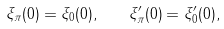Convert formula to latex. <formula><loc_0><loc_0><loc_500><loc_500>\xi _ { \pi } ( 0 ) = \xi _ { 0 } ( 0 ) , \quad \xi _ { \pi } ^ { \prime } ( 0 ) = \xi _ { 0 } ^ { \prime } ( 0 ) ,</formula> 